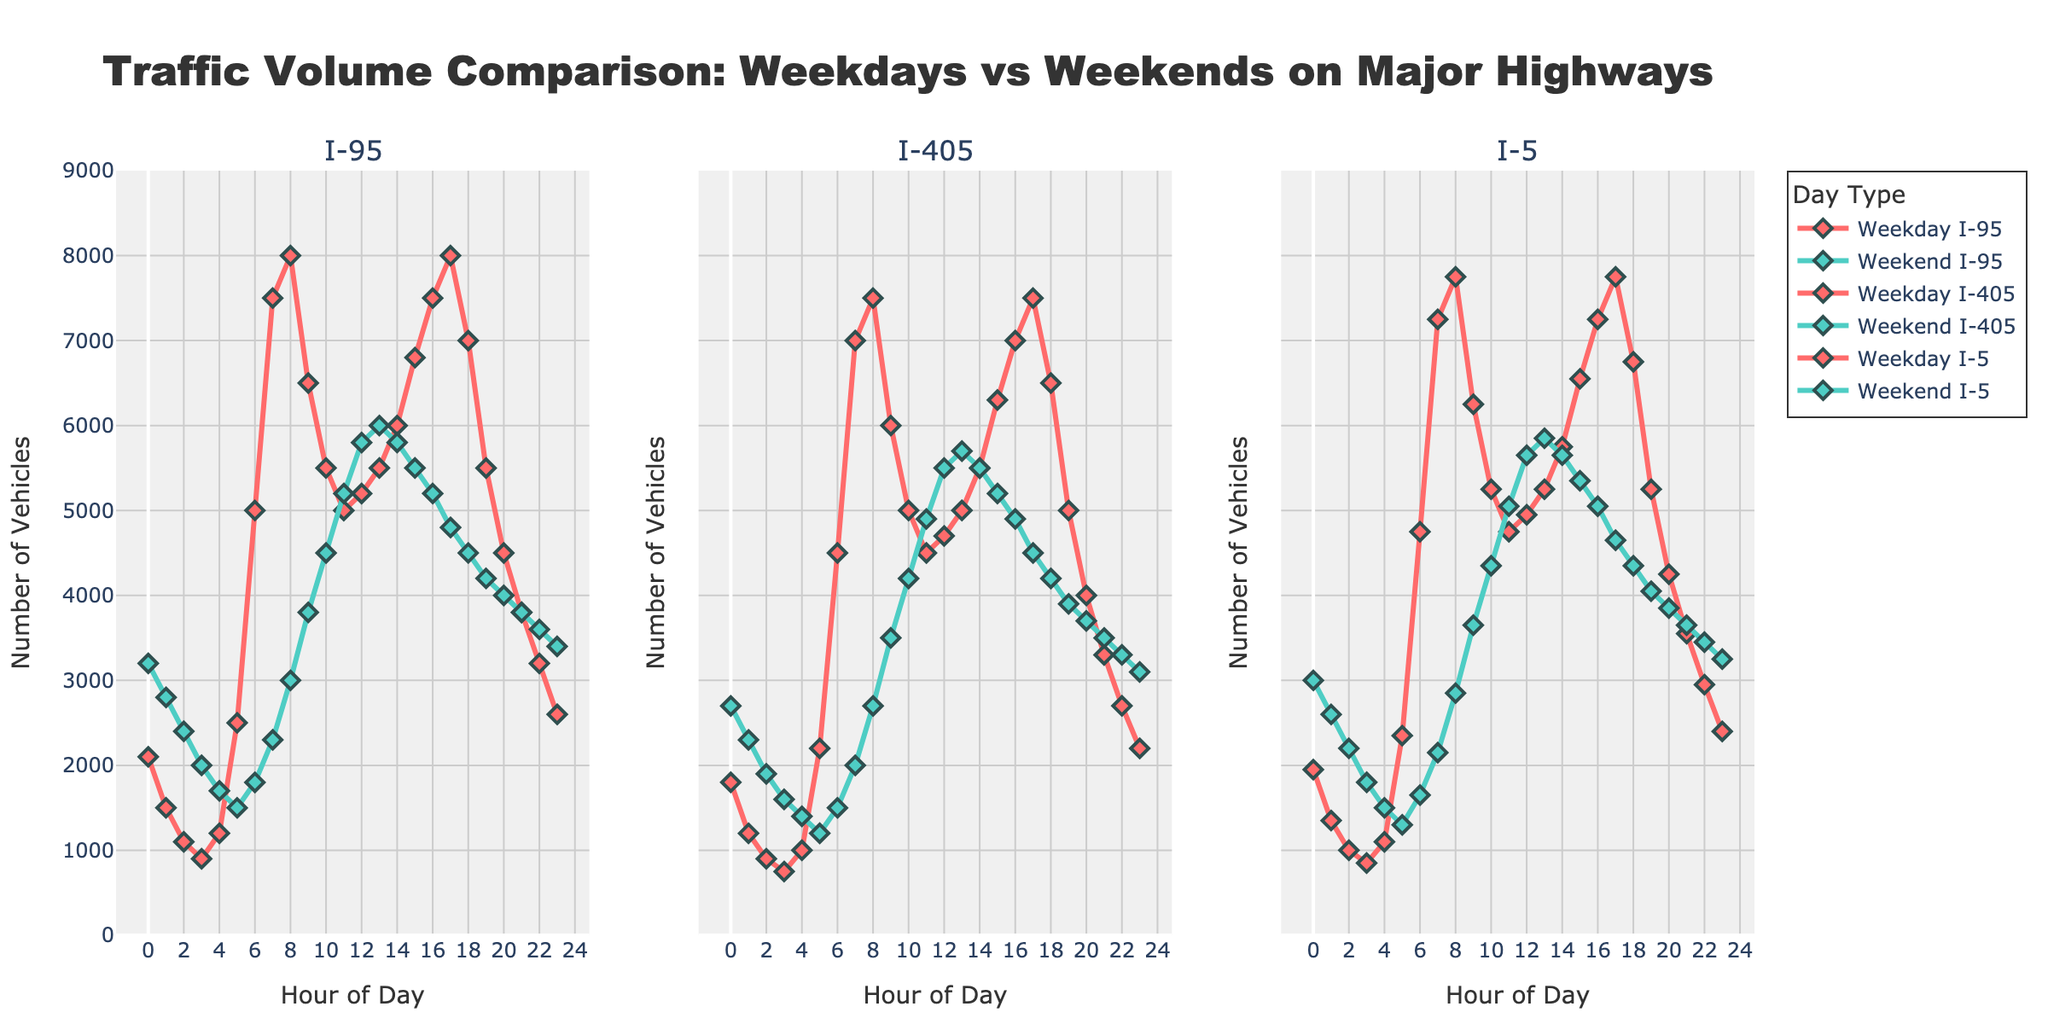Which highway sees the highest traffic volume during weekdays at 8 AM? By observing the heights of the lines at 8 AM on the different plots, we can see that I-95 has the highest traffic volume for weekdays.
Answer: I-95 Comparing weekends, which highway experiences the lowest traffic volume at 5 PM? Looking at the data for 5 PM across the three different highway plots on weekends, I-405 has the lowest traffic volume.
Answer: I-405 What is the difference in traffic volume between weekdays and weekends at midnight (12 AM) on I-95? For I-95 at 12 AM, the weekday traffic volume is 2100 and the weekend volume is 3200. The difference would be 3200 - 2100 = 1100 vehicles.
Answer: 1100 Which highway shows the greatest increase in traffic volume from 3 AM to 6 AM during weekdays? By checking the weekday plots for each highway from 3 AM to 6 AM, I-95 increases from 900 to 5000, I-405 from 750 to 4500, and I-5 from 850 to 4750. The greatest increase is on I-95 (5000-900=4100).
Answer: I-95 At its peak traffic volume during the weekend, what is the traffic volume on I-405? On the weekend plot for I-405, the peak traffic volume is at 11 AM with a volume of 4900 vehicles.
Answer: 4900 Which highway has more consistent traffic volume throughout the day on weekends? By observing the fluctuations in the weekend plots of the three highways, I-5 shows relatively smaller variations throughout the day compared to I-95 and I-405.
Answer: I-5 How much more traffic does I-95 experience at its weekday peak compared to its weekend peak? The peak weekday traffic volume for I-95 is 8000 vehicles at 8 AM, and the peak weekend volume is 6000 vehicles at 1 PM. The difference is 8000 - 6000 = 2000 vehicles.
Answer: 2000 During weekdays, at what time is the traffic volume lowest on I-405? Observing the weekday plot for I-405, the lowest traffic volume is at 3 AM with a value of 750 vehicles.
Answer: 3 AM 